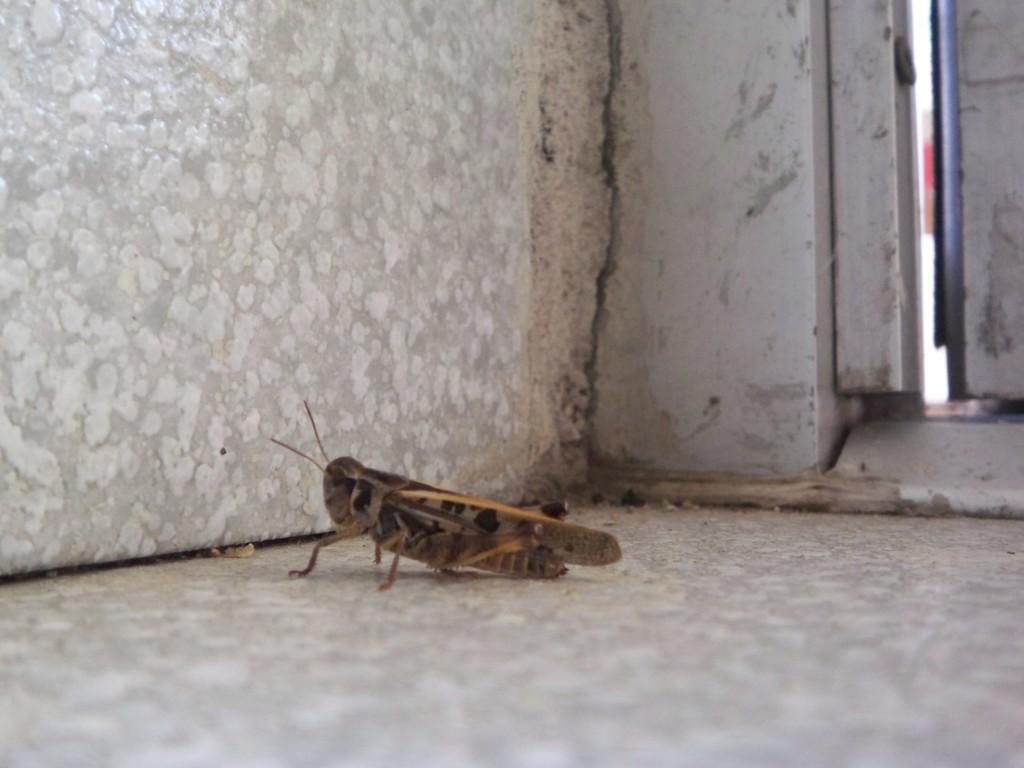Could you give a brief overview of what you see in this image? In this image we can see a grasshopper on the surface, also we can see the walls. 